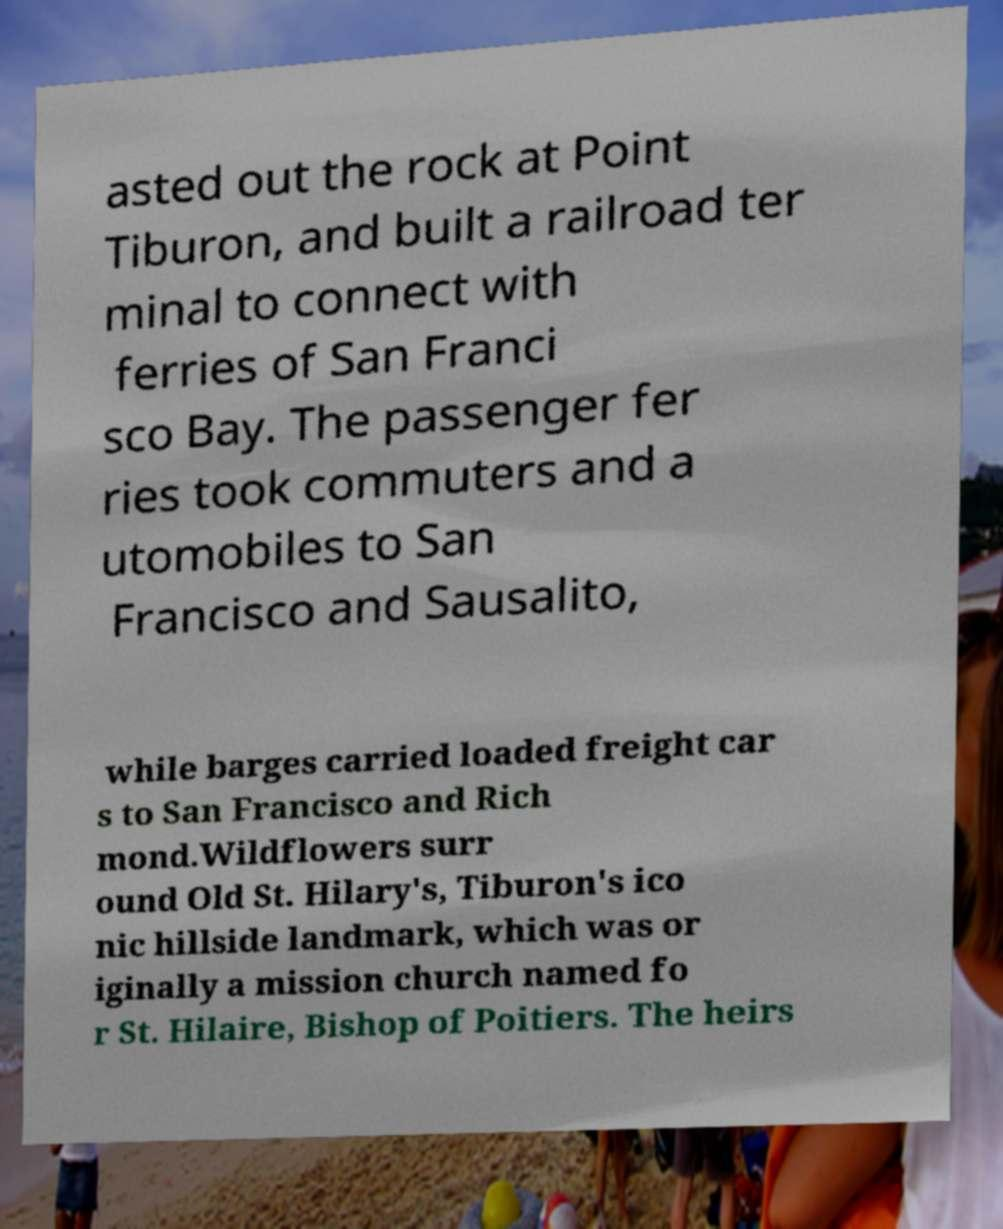Please read and relay the text visible in this image. What does it say? asted out the rock at Point Tiburon, and built a railroad ter minal to connect with ferries of San Franci sco Bay. The passenger fer ries took commuters and a utomobiles to San Francisco and Sausalito, while barges carried loaded freight car s to San Francisco and Rich mond.Wildflowers surr ound Old St. Hilary's, Tiburon's ico nic hillside landmark, which was or iginally a mission church named fo r St. Hilaire, Bishop of Poitiers. The heirs 